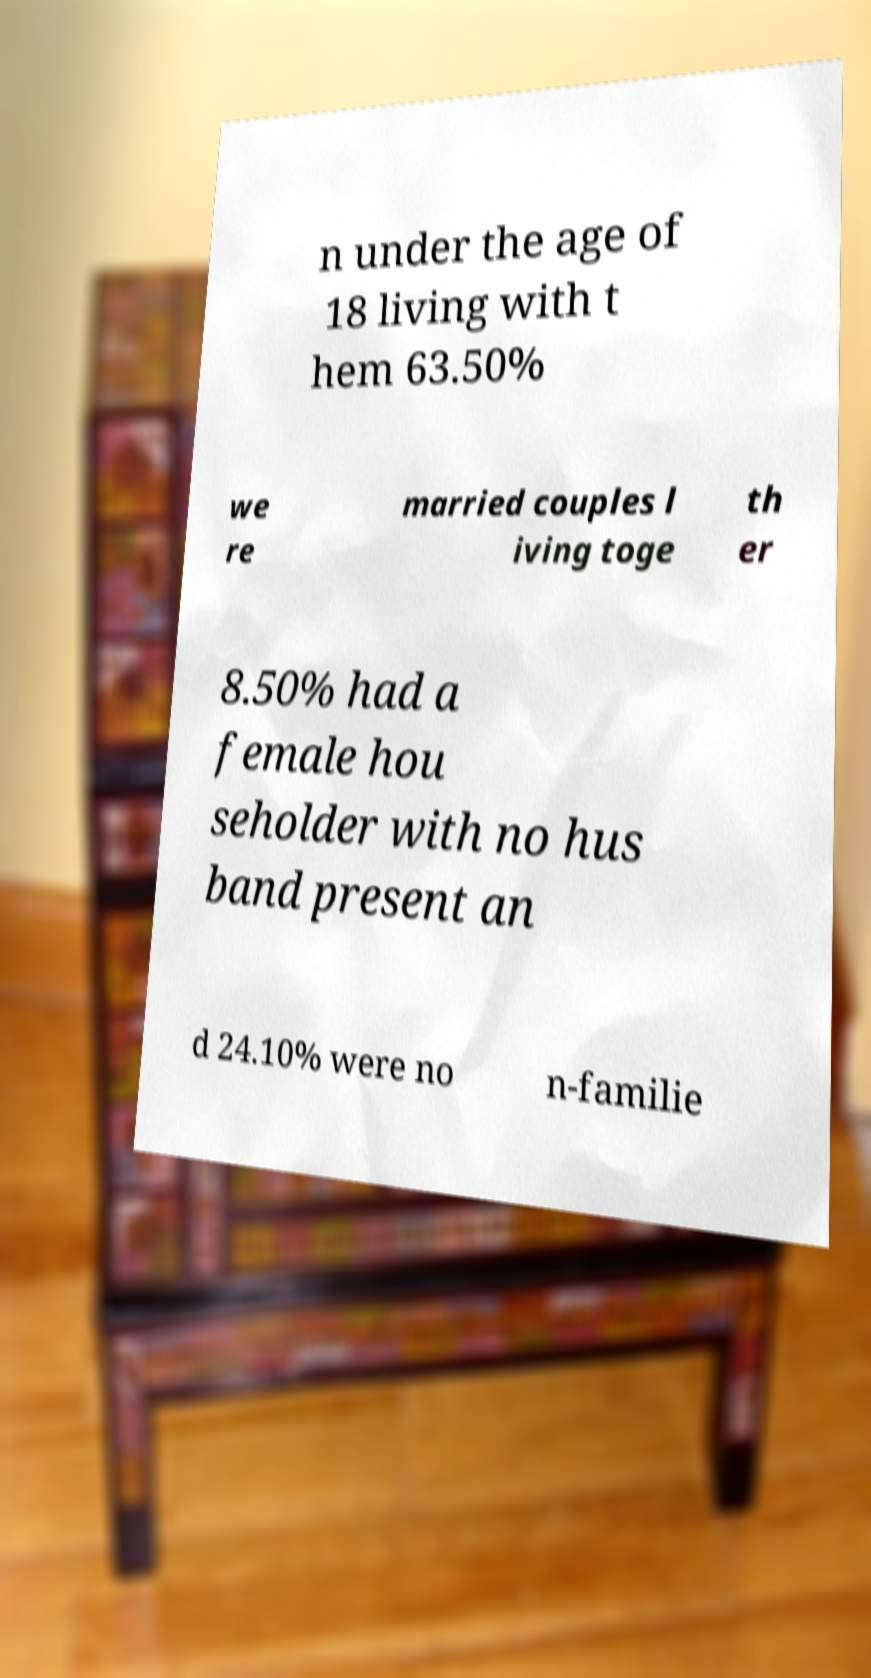There's text embedded in this image that I need extracted. Can you transcribe it verbatim? n under the age of 18 living with t hem 63.50% we re married couples l iving toge th er 8.50% had a female hou seholder with no hus band present an d 24.10% were no n-familie 